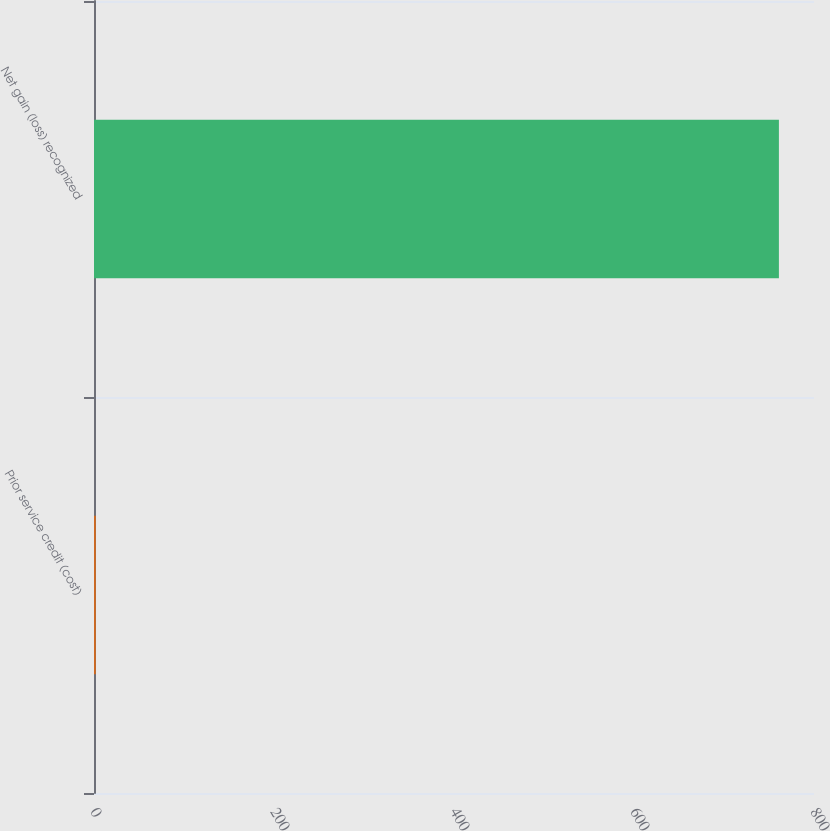Convert chart to OTSL. <chart><loc_0><loc_0><loc_500><loc_500><bar_chart><fcel>Prior service credit (cost)<fcel>Net gain (loss) recognized<nl><fcel>2<fcel>761<nl></chart> 